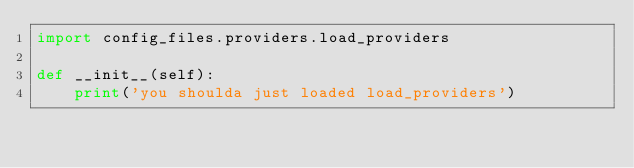Convert code to text. <code><loc_0><loc_0><loc_500><loc_500><_Python_>import config_files.providers.load_providers

def __init__(self):
    print('you shoulda just loaded load_providers')
</code> 